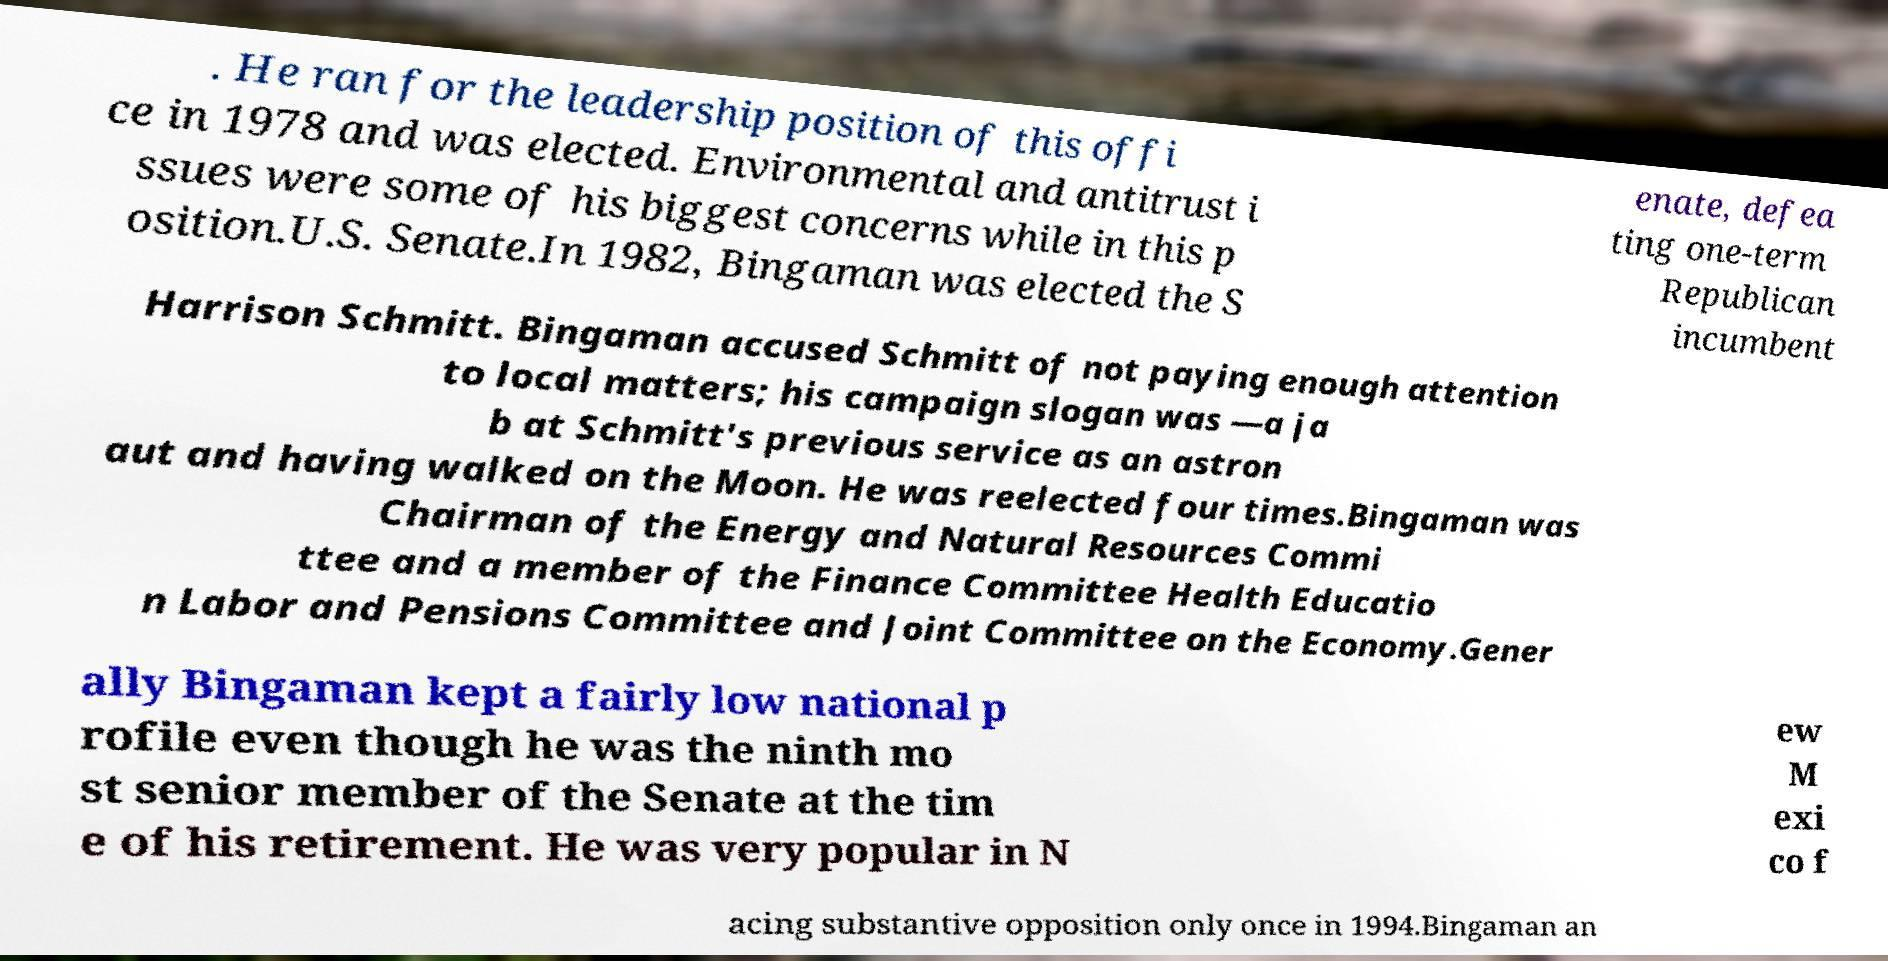Could you extract and type out the text from this image? . He ran for the leadership position of this offi ce in 1978 and was elected. Environmental and antitrust i ssues were some of his biggest concerns while in this p osition.U.S. Senate.In 1982, Bingaman was elected the S enate, defea ting one-term Republican incumbent Harrison Schmitt. Bingaman accused Schmitt of not paying enough attention to local matters; his campaign slogan was —a ja b at Schmitt's previous service as an astron aut and having walked on the Moon. He was reelected four times.Bingaman was Chairman of the Energy and Natural Resources Commi ttee and a member of the Finance Committee Health Educatio n Labor and Pensions Committee and Joint Committee on the Economy.Gener ally Bingaman kept a fairly low national p rofile even though he was the ninth mo st senior member of the Senate at the tim e of his retirement. He was very popular in N ew M exi co f acing substantive opposition only once in 1994.Bingaman an 